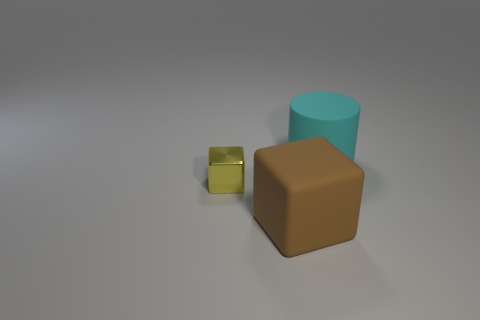How many gray objects are small metal cylinders or shiny cubes?
Provide a short and direct response. 0. How many other objects are the same shape as the metal thing?
Offer a terse response. 1. Are the cylinder and the small yellow cube made of the same material?
Your answer should be very brief. No. There is a object that is in front of the big cyan thing and behind the brown thing; what is its material?
Your answer should be compact. Metal. What color is the thing that is in front of the tiny yellow thing?
Ensure brevity in your answer.  Brown. Are there more big brown cubes that are in front of the big rubber block than cyan cylinders?
Keep it short and to the point. No. How many other things are there of the same size as the brown matte block?
Offer a very short reply. 1. How many large matte things are right of the big brown block?
Provide a succinct answer. 1. Are there the same number of brown matte things on the left side of the tiny cube and large cyan matte cylinders that are to the right of the big brown thing?
Provide a succinct answer. No. There is a yellow shiny thing that is the same shape as the large brown matte object; what size is it?
Provide a succinct answer. Small. 